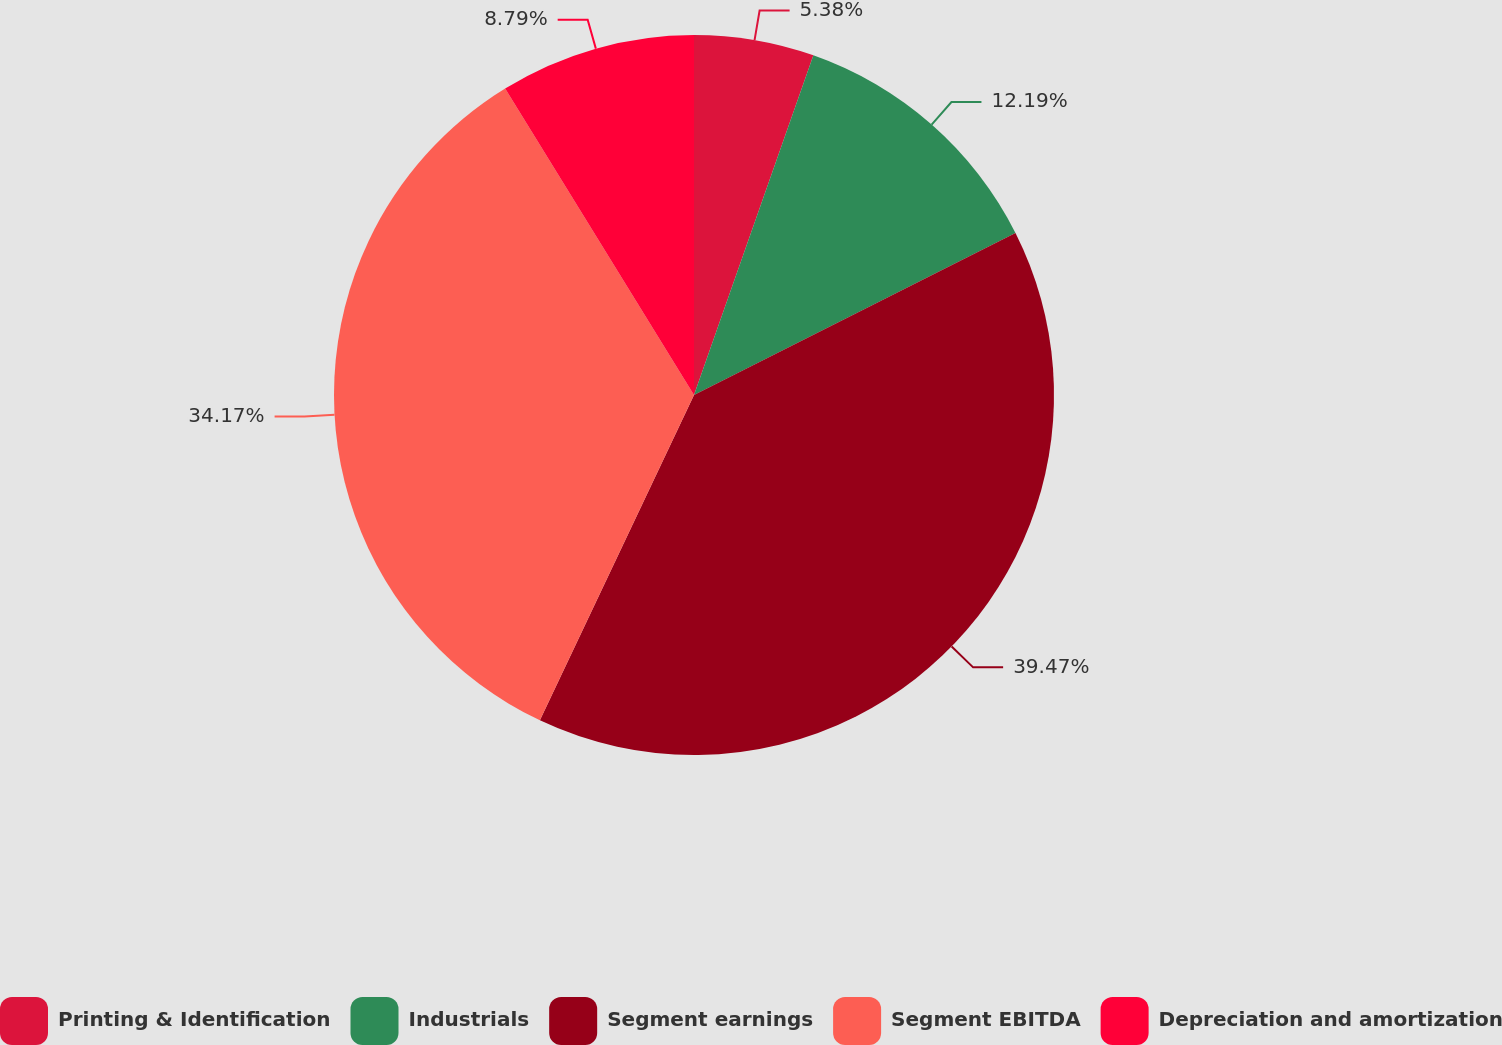Convert chart. <chart><loc_0><loc_0><loc_500><loc_500><pie_chart><fcel>Printing & Identification<fcel>Industrials<fcel>Segment earnings<fcel>Segment EBITDA<fcel>Depreciation and amortization<nl><fcel>5.38%<fcel>12.19%<fcel>39.47%<fcel>34.17%<fcel>8.79%<nl></chart> 